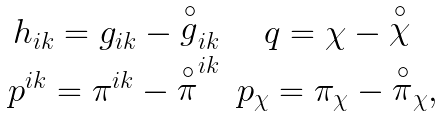Convert formula to latex. <formula><loc_0><loc_0><loc_500><loc_500>\begin{array} { r c l } h _ { i k } = g _ { i k } - { \stackrel { \circ } { g } } _ { i k } & q = \chi - { \stackrel { \circ } { \chi } } \\ p ^ { i k } = \pi ^ { i k } - { \stackrel { \circ } { \pi } } ^ { i k } & p _ { \chi } = \pi _ { \chi } - { \stackrel { \circ } { \pi } } _ { \chi } , \end{array}</formula> 